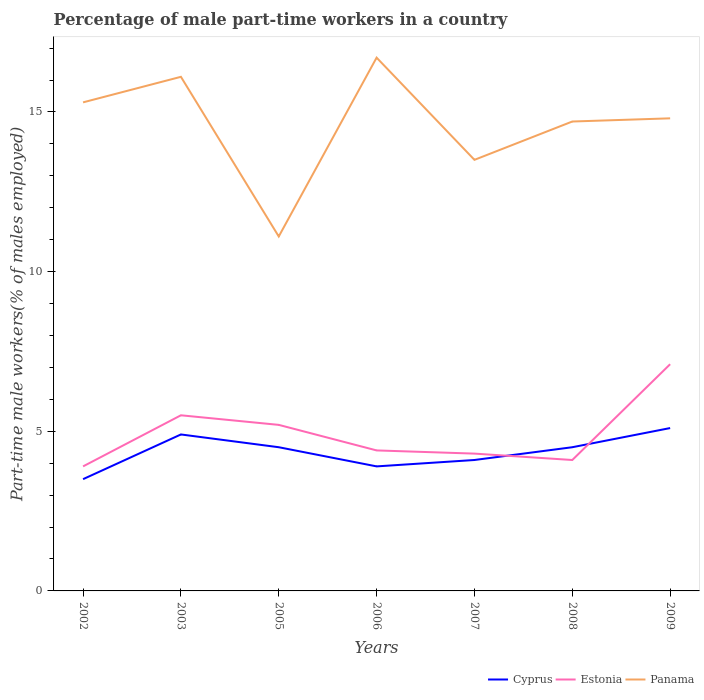Across all years, what is the maximum percentage of male part-time workers in Panama?
Provide a short and direct response. 11.1. What is the total percentage of male part-time workers in Panama in the graph?
Ensure brevity in your answer.  -1.2. What is the difference between the highest and the second highest percentage of male part-time workers in Estonia?
Your answer should be compact. 3.2. What is the difference between the highest and the lowest percentage of male part-time workers in Panama?
Provide a succinct answer. 5. How many lines are there?
Provide a short and direct response. 3. How many years are there in the graph?
Provide a short and direct response. 7. What is the difference between two consecutive major ticks on the Y-axis?
Provide a succinct answer. 5. Are the values on the major ticks of Y-axis written in scientific E-notation?
Ensure brevity in your answer.  No. Where does the legend appear in the graph?
Provide a short and direct response. Bottom right. How are the legend labels stacked?
Offer a very short reply. Horizontal. What is the title of the graph?
Your answer should be compact. Percentage of male part-time workers in a country. What is the label or title of the Y-axis?
Ensure brevity in your answer.  Part-time male workers(% of males employed). What is the Part-time male workers(% of males employed) in Estonia in 2002?
Keep it short and to the point. 3.9. What is the Part-time male workers(% of males employed) of Panama in 2002?
Keep it short and to the point. 15.3. What is the Part-time male workers(% of males employed) in Cyprus in 2003?
Keep it short and to the point. 4.9. What is the Part-time male workers(% of males employed) in Panama in 2003?
Provide a short and direct response. 16.1. What is the Part-time male workers(% of males employed) of Cyprus in 2005?
Offer a very short reply. 4.5. What is the Part-time male workers(% of males employed) in Estonia in 2005?
Provide a succinct answer. 5.2. What is the Part-time male workers(% of males employed) of Panama in 2005?
Offer a very short reply. 11.1. What is the Part-time male workers(% of males employed) of Cyprus in 2006?
Offer a very short reply. 3.9. What is the Part-time male workers(% of males employed) in Estonia in 2006?
Provide a succinct answer. 4.4. What is the Part-time male workers(% of males employed) in Panama in 2006?
Ensure brevity in your answer.  16.7. What is the Part-time male workers(% of males employed) in Cyprus in 2007?
Offer a very short reply. 4.1. What is the Part-time male workers(% of males employed) in Estonia in 2007?
Ensure brevity in your answer.  4.3. What is the Part-time male workers(% of males employed) in Panama in 2007?
Offer a very short reply. 13.5. What is the Part-time male workers(% of males employed) in Estonia in 2008?
Provide a short and direct response. 4.1. What is the Part-time male workers(% of males employed) of Panama in 2008?
Keep it short and to the point. 14.7. What is the Part-time male workers(% of males employed) of Cyprus in 2009?
Your answer should be compact. 5.1. What is the Part-time male workers(% of males employed) in Estonia in 2009?
Provide a short and direct response. 7.1. What is the Part-time male workers(% of males employed) in Panama in 2009?
Give a very brief answer. 14.8. Across all years, what is the maximum Part-time male workers(% of males employed) of Cyprus?
Keep it short and to the point. 5.1. Across all years, what is the maximum Part-time male workers(% of males employed) of Estonia?
Offer a very short reply. 7.1. Across all years, what is the maximum Part-time male workers(% of males employed) of Panama?
Keep it short and to the point. 16.7. Across all years, what is the minimum Part-time male workers(% of males employed) of Estonia?
Your answer should be compact. 3.9. Across all years, what is the minimum Part-time male workers(% of males employed) in Panama?
Your response must be concise. 11.1. What is the total Part-time male workers(% of males employed) of Cyprus in the graph?
Your answer should be compact. 30.5. What is the total Part-time male workers(% of males employed) of Estonia in the graph?
Your answer should be very brief. 34.5. What is the total Part-time male workers(% of males employed) in Panama in the graph?
Your response must be concise. 102.2. What is the difference between the Part-time male workers(% of males employed) of Estonia in 2002 and that in 2003?
Your answer should be very brief. -1.6. What is the difference between the Part-time male workers(% of males employed) in Panama in 2002 and that in 2003?
Your response must be concise. -0.8. What is the difference between the Part-time male workers(% of males employed) of Panama in 2002 and that in 2005?
Give a very brief answer. 4.2. What is the difference between the Part-time male workers(% of males employed) of Cyprus in 2002 and that in 2006?
Your response must be concise. -0.4. What is the difference between the Part-time male workers(% of males employed) in Panama in 2002 and that in 2006?
Keep it short and to the point. -1.4. What is the difference between the Part-time male workers(% of males employed) in Estonia in 2002 and that in 2007?
Your answer should be compact. -0.4. What is the difference between the Part-time male workers(% of males employed) of Panama in 2002 and that in 2007?
Keep it short and to the point. 1.8. What is the difference between the Part-time male workers(% of males employed) of Cyprus in 2002 and that in 2008?
Offer a terse response. -1. What is the difference between the Part-time male workers(% of males employed) of Estonia in 2002 and that in 2008?
Ensure brevity in your answer.  -0.2. What is the difference between the Part-time male workers(% of males employed) in Panama in 2002 and that in 2008?
Offer a very short reply. 0.6. What is the difference between the Part-time male workers(% of males employed) of Panama in 2002 and that in 2009?
Provide a succinct answer. 0.5. What is the difference between the Part-time male workers(% of males employed) in Cyprus in 2003 and that in 2005?
Make the answer very short. 0.4. What is the difference between the Part-time male workers(% of males employed) of Cyprus in 2003 and that in 2006?
Your answer should be very brief. 1. What is the difference between the Part-time male workers(% of males employed) of Panama in 2003 and that in 2006?
Give a very brief answer. -0.6. What is the difference between the Part-time male workers(% of males employed) of Cyprus in 2003 and that in 2008?
Ensure brevity in your answer.  0.4. What is the difference between the Part-time male workers(% of males employed) of Panama in 2003 and that in 2008?
Your answer should be very brief. 1.4. What is the difference between the Part-time male workers(% of males employed) in Estonia in 2003 and that in 2009?
Ensure brevity in your answer.  -1.6. What is the difference between the Part-time male workers(% of males employed) in Cyprus in 2005 and that in 2006?
Keep it short and to the point. 0.6. What is the difference between the Part-time male workers(% of males employed) of Estonia in 2005 and that in 2007?
Your answer should be compact. 0.9. What is the difference between the Part-time male workers(% of males employed) in Estonia in 2005 and that in 2008?
Ensure brevity in your answer.  1.1. What is the difference between the Part-time male workers(% of males employed) of Estonia in 2005 and that in 2009?
Your response must be concise. -1.9. What is the difference between the Part-time male workers(% of males employed) of Panama in 2005 and that in 2009?
Your answer should be compact. -3.7. What is the difference between the Part-time male workers(% of males employed) in Cyprus in 2006 and that in 2007?
Your answer should be very brief. -0.2. What is the difference between the Part-time male workers(% of males employed) of Panama in 2006 and that in 2008?
Ensure brevity in your answer.  2. What is the difference between the Part-time male workers(% of males employed) of Cyprus in 2006 and that in 2009?
Offer a terse response. -1.2. What is the difference between the Part-time male workers(% of males employed) of Cyprus in 2007 and that in 2008?
Ensure brevity in your answer.  -0.4. What is the difference between the Part-time male workers(% of males employed) of Estonia in 2007 and that in 2008?
Offer a very short reply. 0.2. What is the difference between the Part-time male workers(% of males employed) of Estonia in 2007 and that in 2009?
Keep it short and to the point. -2.8. What is the difference between the Part-time male workers(% of males employed) in Panama in 2007 and that in 2009?
Provide a short and direct response. -1.3. What is the difference between the Part-time male workers(% of males employed) of Cyprus in 2002 and the Part-time male workers(% of males employed) of Estonia in 2003?
Ensure brevity in your answer.  -2. What is the difference between the Part-time male workers(% of males employed) of Cyprus in 2002 and the Part-time male workers(% of males employed) of Panama in 2003?
Provide a succinct answer. -12.6. What is the difference between the Part-time male workers(% of males employed) of Estonia in 2002 and the Part-time male workers(% of males employed) of Panama in 2003?
Keep it short and to the point. -12.2. What is the difference between the Part-time male workers(% of males employed) in Cyprus in 2002 and the Part-time male workers(% of males employed) in Panama in 2005?
Offer a very short reply. -7.6. What is the difference between the Part-time male workers(% of males employed) in Cyprus in 2002 and the Part-time male workers(% of males employed) in Panama in 2006?
Your answer should be compact. -13.2. What is the difference between the Part-time male workers(% of males employed) of Estonia in 2002 and the Part-time male workers(% of males employed) of Panama in 2007?
Give a very brief answer. -9.6. What is the difference between the Part-time male workers(% of males employed) of Cyprus in 2002 and the Part-time male workers(% of males employed) of Panama in 2008?
Offer a terse response. -11.2. What is the difference between the Part-time male workers(% of males employed) in Cyprus in 2002 and the Part-time male workers(% of males employed) in Estonia in 2009?
Provide a succinct answer. -3.6. What is the difference between the Part-time male workers(% of males employed) of Estonia in 2003 and the Part-time male workers(% of males employed) of Panama in 2005?
Your answer should be very brief. -5.6. What is the difference between the Part-time male workers(% of males employed) of Cyprus in 2003 and the Part-time male workers(% of males employed) of Estonia in 2006?
Make the answer very short. 0.5. What is the difference between the Part-time male workers(% of males employed) in Estonia in 2003 and the Part-time male workers(% of males employed) in Panama in 2006?
Offer a terse response. -11.2. What is the difference between the Part-time male workers(% of males employed) in Estonia in 2003 and the Part-time male workers(% of males employed) in Panama in 2008?
Offer a very short reply. -9.2. What is the difference between the Part-time male workers(% of males employed) in Cyprus in 2003 and the Part-time male workers(% of males employed) in Panama in 2009?
Your response must be concise. -9.9. What is the difference between the Part-time male workers(% of males employed) in Cyprus in 2005 and the Part-time male workers(% of males employed) in Estonia in 2006?
Provide a short and direct response. 0.1. What is the difference between the Part-time male workers(% of males employed) of Cyprus in 2005 and the Part-time male workers(% of males employed) of Panama in 2006?
Provide a short and direct response. -12.2. What is the difference between the Part-time male workers(% of males employed) of Estonia in 2005 and the Part-time male workers(% of males employed) of Panama in 2006?
Provide a short and direct response. -11.5. What is the difference between the Part-time male workers(% of males employed) of Cyprus in 2005 and the Part-time male workers(% of males employed) of Estonia in 2007?
Keep it short and to the point. 0.2. What is the difference between the Part-time male workers(% of males employed) in Estonia in 2005 and the Part-time male workers(% of males employed) in Panama in 2007?
Provide a short and direct response. -8.3. What is the difference between the Part-time male workers(% of males employed) in Cyprus in 2005 and the Part-time male workers(% of males employed) in Panama in 2008?
Make the answer very short. -10.2. What is the difference between the Part-time male workers(% of males employed) in Estonia in 2005 and the Part-time male workers(% of males employed) in Panama in 2008?
Your answer should be very brief. -9.5. What is the difference between the Part-time male workers(% of males employed) of Cyprus in 2005 and the Part-time male workers(% of males employed) of Estonia in 2009?
Keep it short and to the point. -2.6. What is the difference between the Part-time male workers(% of males employed) in Cyprus in 2005 and the Part-time male workers(% of males employed) in Panama in 2009?
Provide a succinct answer. -10.3. What is the difference between the Part-time male workers(% of males employed) of Estonia in 2005 and the Part-time male workers(% of males employed) of Panama in 2009?
Your answer should be very brief. -9.6. What is the difference between the Part-time male workers(% of males employed) of Cyprus in 2006 and the Part-time male workers(% of males employed) of Estonia in 2007?
Your response must be concise. -0.4. What is the difference between the Part-time male workers(% of males employed) of Cyprus in 2006 and the Part-time male workers(% of males employed) of Panama in 2008?
Your answer should be very brief. -10.8. What is the difference between the Part-time male workers(% of males employed) of Cyprus in 2006 and the Part-time male workers(% of males employed) of Estonia in 2009?
Provide a short and direct response. -3.2. What is the difference between the Part-time male workers(% of males employed) in Cyprus in 2006 and the Part-time male workers(% of males employed) in Panama in 2009?
Provide a short and direct response. -10.9. What is the difference between the Part-time male workers(% of males employed) of Estonia in 2006 and the Part-time male workers(% of males employed) of Panama in 2009?
Provide a short and direct response. -10.4. What is the difference between the Part-time male workers(% of males employed) of Cyprus in 2007 and the Part-time male workers(% of males employed) of Panama in 2009?
Provide a succinct answer. -10.7. What is the difference between the Part-time male workers(% of males employed) in Cyprus in 2008 and the Part-time male workers(% of males employed) in Estonia in 2009?
Provide a succinct answer. -2.6. What is the difference between the Part-time male workers(% of males employed) of Estonia in 2008 and the Part-time male workers(% of males employed) of Panama in 2009?
Give a very brief answer. -10.7. What is the average Part-time male workers(% of males employed) in Cyprus per year?
Offer a very short reply. 4.36. What is the average Part-time male workers(% of males employed) in Estonia per year?
Make the answer very short. 4.93. What is the average Part-time male workers(% of males employed) in Panama per year?
Ensure brevity in your answer.  14.6. In the year 2002, what is the difference between the Part-time male workers(% of males employed) of Estonia and Part-time male workers(% of males employed) of Panama?
Provide a succinct answer. -11.4. In the year 2005, what is the difference between the Part-time male workers(% of males employed) of Cyprus and Part-time male workers(% of males employed) of Estonia?
Your response must be concise. -0.7. In the year 2005, what is the difference between the Part-time male workers(% of males employed) of Cyprus and Part-time male workers(% of males employed) of Panama?
Give a very brief answer. -6.6. In the year 2006, what is the difference between the Part-time male workers(% of males employed) in Cyprus and Part-time male workers(% of males employed) in Panama?
Your answer should be compact. -12.8. In the year 2006, what is the difference between the Part-time male workers(% of males employed) in Estonia and Part-time male workers(% of males employed) in Panama?
Offer a very short reply. -12.3. In the year 2007, what is the difference between the Part-time male workers(% of males employed) of Cyprus and Part-time male workers(% of males employed) of Panama?
Your response must be concise. -9.4. In the year 2008, what is the difference between the Part-time male workers(% of males employed) of Estonia and Part-time male workers(% of males employed) of Panama?
Ensure brevity in your answer.  -10.6. In the year 2009, what is the difference between the Part-time male workers(% of males employed) of Cyprus and Part-time male workers(% of males employed) of Panama?
Give a very brief answer. -9.7. In the year 2009, what is the difference between the Part-time male workers(% of males employed) in Estonia and Part-time male workers(% of males employed) in Panama?
Give a very brief answer. -7.7. What is the ratio of the Part-time male workers(% of males employed) of Cyprus in 2002 to that in 2003?
Give a very brief answer. 0.71. What is the ratio of the Part-time male workers(% of males employed) in Estonia in 2002 to that in 2003?
Offer a terse response. 0.71. What is the ratio of the Part-time male workers(% of males employed) of Panama in 2002 to that in 2003?
Keep it short and to the point. 0.95. What is the ratio of the Part-time male workers(% of males employed) in Estonia in 2002 to that in 2005?
Provide a succinct answer. 0.75. What is the ratio of the Part-time male workers(% of males employed) in Panama in 2002 to that in 2005?
Make the answer very short. 1.38. What is the ratio of the Part-time male workers(% of males employed) in Cyprus in 2002 to that in 2006?
Provide a short and direct response. 0.9. What is the ratio of the Part-time male workers(% of males employed) in Estonia in 2002 to that in 2006?
Ensure brevity in your answer.  0.89. What is the ratio of the Part-time male workers(% of males employed) in Panama in 2002 to that in 2006?
Your answer should be compact. 0.92. What is the ratio of the Part-time male workers(% of males employed) in Cyprus in 2002 to that in 2007?
Ensure brevity in your answer.  0.85. What is the ratio of the Part-time male workers(% of males employed) of Estonia in 2002 to that in 2007?
Provide a succinct answer. 0.91. What is the ratio of the Part-time male workers(% of males employed) in Panama in 2002 to that in 2007?
Ensure brevity in your answer.  1.13. What is the ratio of the Part-time male workers(% of males employed) of Estonia in 2002 to that in 2008?
Provide a succinct answer. 0.95. What is the ratio of the Part-time male workers(% of males employed) of Panama in 2002 to that in 2008?
Make the answer very short. 1.04. What is the ratio of the Part-time male workers(% of males employed) in Cyprus in 2002 to that in 2009?
Provide a succinct answer. 0.69. What is the ratio of the Part-time male workers(% of males employed) of Estonia in 2002 to that in 2009?
Keep it short and to the point. 0.55. What is the ratio of the Part-time male workers(% of males employed) in Panama in 2002 to that in 2009?
Ensure brevity in your answer.  1.03. What is the ratio of the Part-time male workers(% of males employed) in Cyprus in 2003 to that in 2005?
Your answer should be very brief. 1.09. What is the ratio of the Part-time male workers(% of males employed) in Estonia in 2003 to that in 2005?
Provide a succinct answer. 1.06. What is the ratio of the Part-time male workers(% of males employed) of Panama in 2003 to that in 2005?
Your answer should be very brief. 1.45. What is the ratio of the Part-time male workers(% of males employed) of Cyprus in 2003 to that in 2006?
Provide a short and direct response. 1.26. What is the ratio of the Part-time male workers(% of males employed) in Panama in 2003 to that in 2006?
Offer a very short reply. 0.96. What is the ratio of the Part-time male workers(% of males employed) of Cyprus in 2003 to that in 2007?
Offer a very short reply. 1.2. What is the ratio of the Part-time male workers(% of males employed) of Estonia in 2003 to that in 2007?
Provide a succinct answer. 1.28. What is the ratio of the Part-time male workers(% of males employed) in Panama in 2003 to that in 2007?
Your answer should be compact. 1.19. What is the ratio of the Part-time male workers(% of males employed) of Cyprus in 2003 to that in 2008?
Ensure brevity in your answer.  1.09. What is the ratio of the Part-time male workers(% of males employed) in Estonia in 2003 to that in 2008?
Your response must be concise. 1.34. What is the ratio of the Part-time male workers(% of males employed) in Panama in 2003 to that in 2008?
Your response must be concise. 1.1. What is the ratio of the Part-time male workers(% of males employed) in Cyprus in 2003 to that in 2009?
Your answer should be compact. 0.96. What is the ratio of the Part-time male workers(% of males employed) of Estonia in 2003 to that in 2009?
Offer a very short reply. 0.77. What is the ratio of the Part-time male workers(% of males employed) in Panama in 2003 to that in 2009?
Offer a terse response. 1.09. What is the ratio of the Part-time male workers(% of males employed) of Cyprus in 2005 to that in 2006?
Offer a very short reply. 1.15. What is the ratio of the Part-time male workers(% of males employed) of Estonia in 2005 to that in 2006?
Give a very brief answer. 1.18. What is the ratio of the Part-time male workers(% of males employed) in Panama in 2005 to that in 2006?
Offer a terse response. 0.66. What is the ratio of the Part-time male workers(% of males employed) of Cyprus in 2005 to that in 2007?
Ensure brevity in your answer.  1.1. What is the ratio of the Part-time male workers(% of males employed) in Estonia in 2005 to that in 2007?
Offer a very short reply. 1.21. What is the ratio of the Part-time male workers(% of males employed) of Panama in 2005 to that in 2007?
Your answer should be compact. 0.82. What is the ratio of the Part-time male workers(% of males employed) of Estonia in 2005 to that in 2008?
Keep it short and to the point. 1.27. What is the ratio of the Part-time male workers(% of males employed) of Panama in 2005 to that in 2008?
Offer a very short reply. 0.76. What is the ratio of the Part-time male workers(% of males employed) in Cyprus in 2005 to that in 2009?
Offer a terse response. 0.88. What is the ratio of the Part-time male workers(% of males employed) of Estonia in 2005 to that in 2009?
Your answer should be very brief. 0.73. What is the ratio of the Part-time male workers(% of males employed) in Panama in 2005 to that in 2009?
Provide a short and direct response. 0.75. What is the ratio of the Part-time male workers(% of males employed) in Cyprus in 2006 to that in 2007?
Your answer should be compact. 0.95. What is the ratio of the Part-time male workers(% of males employed) of Estonia in 2006 to that in 2007?
Offer a terse response. 1.02. What is the ratio of the Part-time male workers(% of males employed) of Panama in 2006 to that in 2007?
Offer a very short reply. 1.24. What is the ratio of the Part-time male workers(% of males employed) of Cyprus in 2006 to that in 2008?
Your answer should be very brief. 0.87. What is the ratio of the Part-time male workers(% of males employed) of Estonia in 2006 to that in 2008?
Keep it short and to the point. 1.07. What is the ratio of the Part-time male workers(% of males employed) in Panama in 2006 to that in 2008?
Provide a short and direct response. 1.14. What is the ratio of the Part-time male workers(% of males employed) in Cyprus in 2006 to that in 2009?
Your answer should be compact. 0.76. What is the ratio of the Part-time male workers(% of males employed) in Estonia in 2006 to that in 2009?
Your answer should be compact. 0.62. What is the ratio of the Part-time male workers(% of males employed) of Panama in 2006 to that in 2009?
Your response must be concise. 1.13. What is the ratio of the Part-time male workers(% of males employed) in Cyprus in 2007 to that in 2008?
Offer a terse response. 0.91. What is the ratio of the Part-time male workers(% of males employed) in Estonia in 2007 to that in 2008?
Your response must be concise. 1.05. What is the ratio of the Part-time male workers(% of males employed) in Panama in 2007 to that in 2008?
Offer a terse response. 0.92. What is the ratio of the Part-time male workers(% of males employed) in Cyprus in 2007 to that in 2009?
Offer a terse response. 0.8. What is the ratio of the Part-time male workers(% of males employed) in Estonia in 2007 to that in 2009?
Offer a terse response. 0.61. What is the ratio of the Part-time male workers(% of males employed) of Panama in 2007 to that in 2009?
Keep it short and to the point. 0.91. What is the ratio of the Part-time male workers(% of males employed) of Cyprus in 2008 to that in 2009?
Ensure brevity in your answer.  0.88. What is the ratio of the Part-time male workers(% of males employed) in Estonia in 2008 to that in 2009?
Make the answer very short. 0.58. What is the ratio of the Part-time male workers(% of males employed) of Panama in 2008 to that in 2009?
Give a very brief answer. 0.99. What is the difference between the highest and the second highest Part-time male workers(% of males employed) of Cyprus?
Keep it short and to the point. 0.2. What is the difference between the highest and the lowest Part-time male workers(% of males employed) of Estonia?
Offer a very short reply. 3.2. What is the difference between the highest and the lowest Part-time male workers(% of males employed) in Panama?
Ensure brevity in your answer.  5.6. 